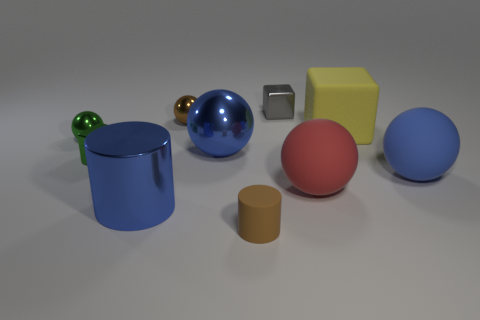How many things are either blue spheres that are on the right side of the big yellow cube or small spheres?
Your answer should be compact. 3. What material is the blue ball that is right of the small metallic cube right of the blue object that is in front of the blue rubber ball?
Your response must be concise. Rubber. Is the number of big yellow rubber things that are right of the large red rubber thing greater than the number of big balls that are behind the small brown ball?
Provide a short and direct response. Yes. What number of cylinders are brown rubber objects or green rubber things?
Give a very brief answer. 1. What number of small things are behind the small shiny cube that is in front of the big metallic object that is behind the big blue rubber thing?
Offer a very short reply. 3. What material is the small ball that is the same color as the small rubber cylinder?
Your answer should be compact. Metal. Are there more big blue metallic things than tiny gray metal balls?
Give a very brief answer. Yes. Is the size of the blue rubber thing the same as the blue cylinder?
Keep it short and to the point. Yes. What number of things are either small metal blocks or tiny green shiny objects?
Provide a short and direct response. 3. There is a blue thing that is in front of the rubber ball that is in front of the large blue object right of the tiny gray shiny thing; what is its shape?
Provide a succinct answer. Cylinder. 